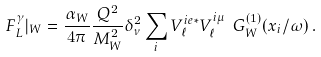Convert formula to latex. <formula><loc_0><loc_0><loc_500><loc_500>F _ { L } ^ { \gamma } | _ { W } = \frac { \alpha _ { W } } { 4 \pi } \frac { Q ^ { 2 } } { M _ { W } ^ { 2 } } \delta _ { \nu } ^ { 2 } \sum _ { i } V ^ { i e * } _ { \ell } V ^ { i \mu } _ { \ell } \ G _ { W } ^ { ( 1 ) } ( x _ { i } / \omega ) \, .</formula> 